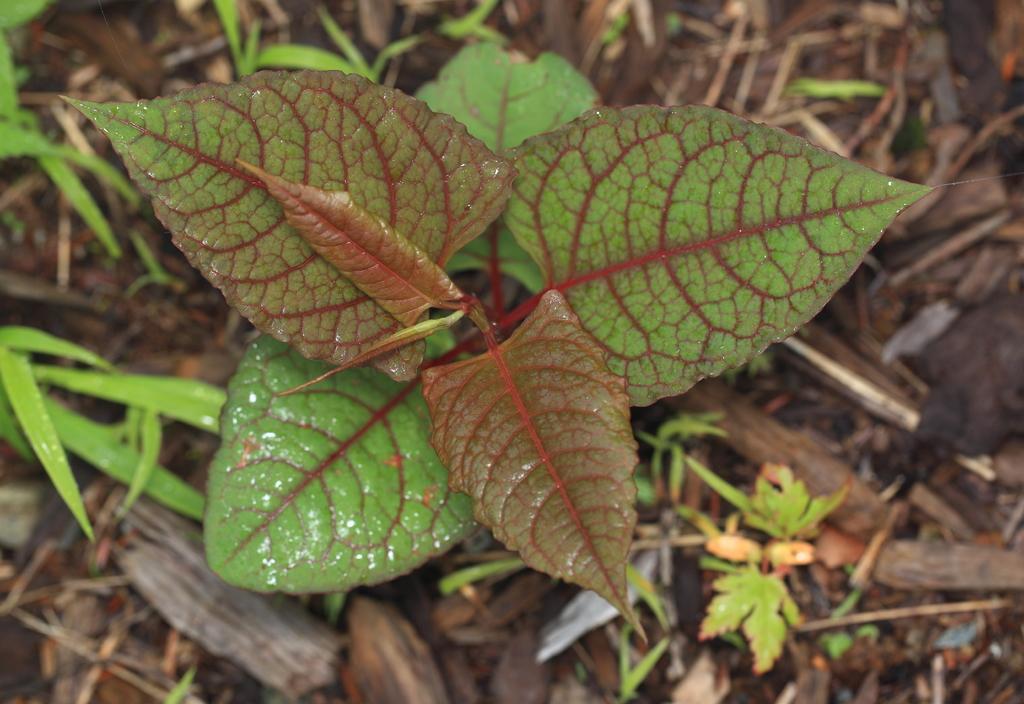Could you give a brief overview of what you see in this image? In this picture we can see a plant, where we can see grass, wooden sticks on the ground. 